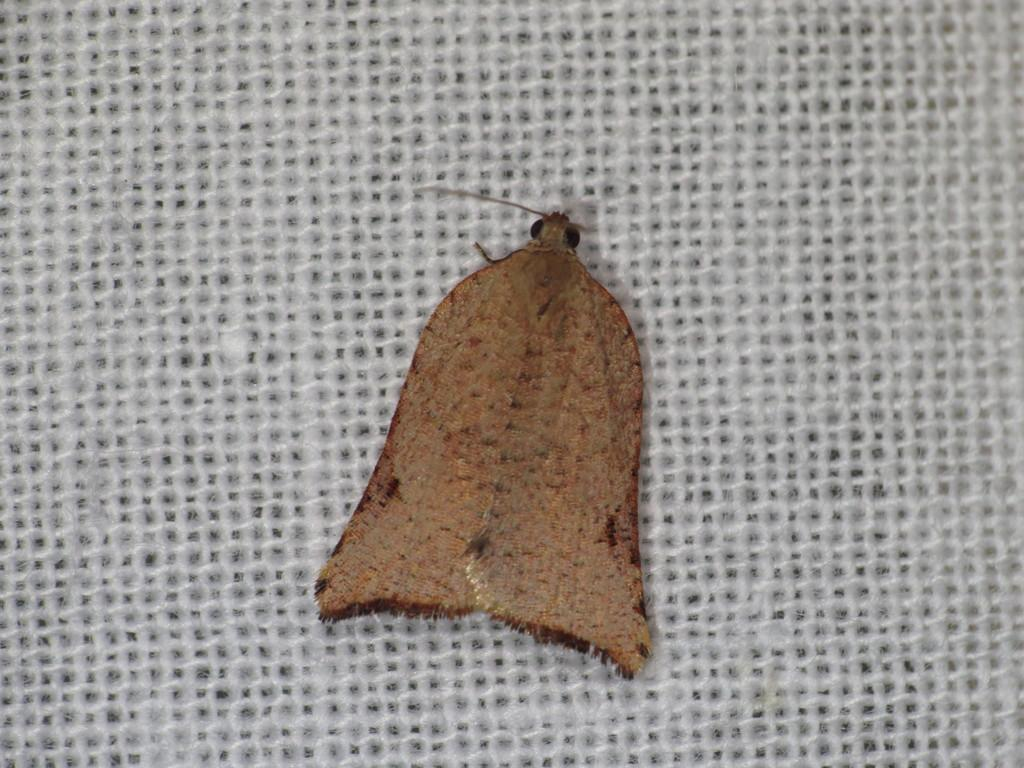What is the main subject of the image? The main subject of the image is a fly. Where is the fly located in the image? The fly is on a net in the image. Can you describe the position of the fly in the image? The fly is in the center of the image. What type of cream is being used to gain the fly's approval in the image? There is no cream or approval-seeking behavior present in the image; it simply shows a fly on a net. 